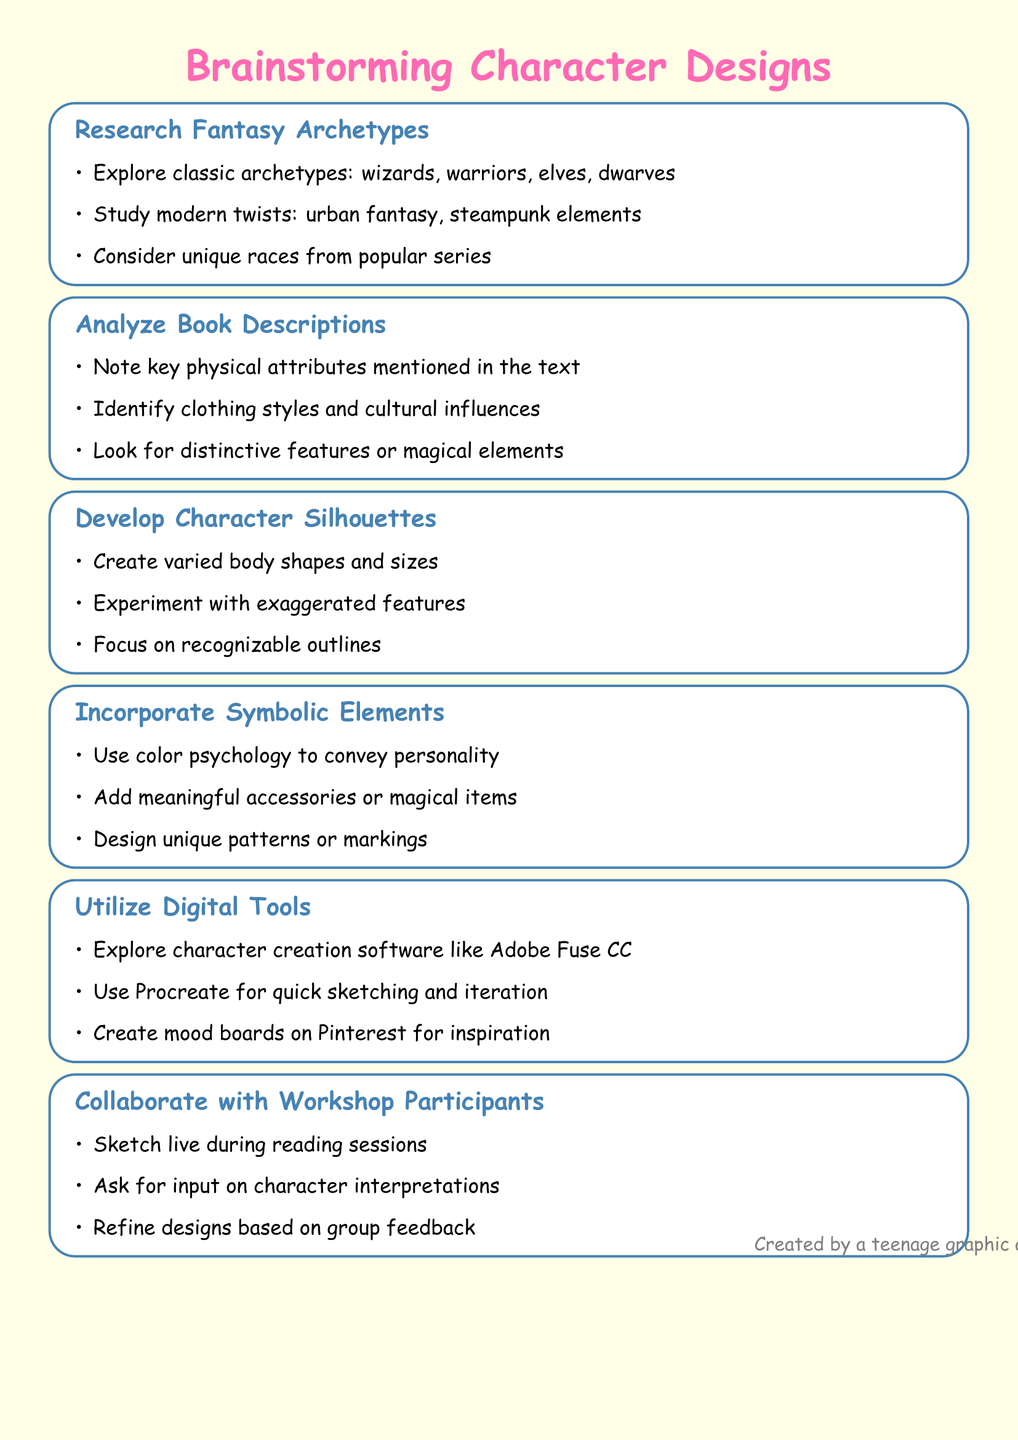What is the title of the document? The title of the document is explicitly stated at the beginning, describing the main focus of the content.
Answer: Brainstorming Character Designs for Fantasy Novel Illustrations How many key points are in the document? The document lists several sections, each containing crucial ideas related to character design.
Answer: Six What is one classic fantasy archetype mentioned? The document highlights classic archetypes in the section discussing fantasy archetypes.
Answer: Wizards Which software is suggested for quick sketching? The document details various digital tools, particularly mentioning Procreate for swift illustration.
Answer: Procreate What type of character designs should be created according to the notes? The notes emphasize the importance of specific shapes and sizes in body design.
Answer: Varied body shapes and sizes What is a method to gather input from workshop participants? Engaging with participants effectively is a strategy listed in the collaboration section of the document.
Answer: Ask for input on character interpretations 